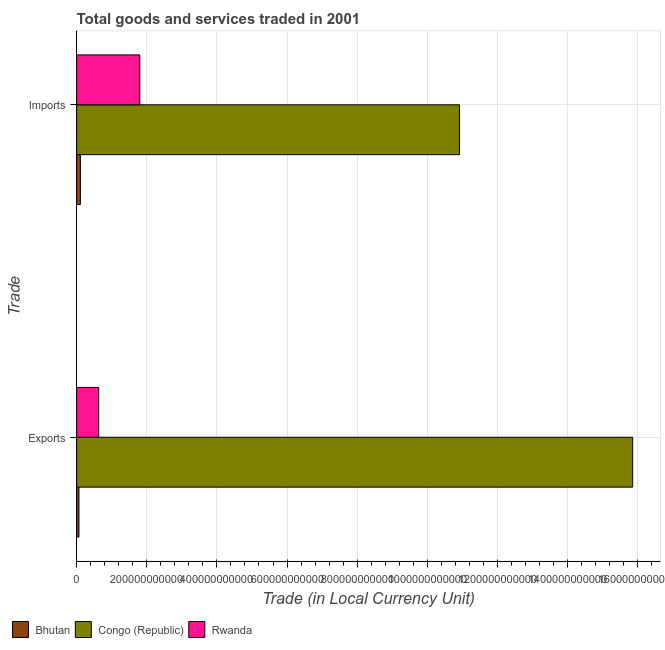How many groups of bars are there?
Your answer should be very brief. 2. Are the number of bars per tick equal to the number of legend labels?
Make the answer very short. Yes. How many bars are there on the 2nd tick from the bottom?
Offer a terse response. 3. What is the label of the 1st group of bars from the top?
Your answer should be compact. Imports. What is the imports of goods and services in Congo (Republic)?
Provide a short and direct response. 1.09e+12. Across all countries, what is the maximum export of goods and services?
Your answer should be compact. 1.59e+12. Across all countries, what is the minimum export of goods and services?
Your answer should be very brief. 6.51e+09. In which country was the export of goods and services maximum?
Give a very brief answer. Congo (Republic). In which country was the imports of goods and services minimum?
Your answer should be compact. Bhutan. What is the total export of goods and services in the graph?
Provide a short and direct response. 1.66e+12. What is the difference between the export of goods and services in Bhutan and that in Congo (Republic)?
Give a very brief answer. -1.58e+12. What is the difference between the imports of goods and services in Bhutan and the export of goods and services in Rwanda?
Your response must be concise. -5.23e+1. What is the average imports of goods and services per country?
Your answer should be compact. 4.28e+11. What is the difference between the imports of goods and services and export of goods and services in Bhutan?
Ensure brevity in your answer.  4.12e+09. In how many countries, is the export of goods and services greater than 80000000000 LCU?
Your answer should be compact. 1. What is the ratio of the export of goods and services in Rwanda to that in Congo (Republic)?
Your answer should be very brief. 0.04. In how many countries, is the imports of goods and services greater than the average imports of goods and services taken over all countries?
Ensure brevity in your answer.  1. What does the 2nd bar from the top in Exports represents?
Provide a short and direct response. Congo (Republic). What does the 1st bar from the bottom in Exports represents?
Ensure brevity in your answer.  Bhutan. How many countries are there in the graph?
Give a very brief answer. 3. What is the difference between two consecutive major ticks on the X-axis?
Offer a terse response. 2.00e+11. Are the values on the major ticks of X-axis written in scientific E-notation?
Provide a succinct answer. No. Does the graph contain grids?
Your answer should be very brief. Yes. What is the title of the graph?
Provide a succinct answer. Total goods and services traded in 2001. Does "Japan" appear as one of the legend labels in the graph?
Offer a very short reply. No. What is the label or title of the X-axis?
Your answer should be compact. Trade (in Local Currency Unit). What is the label or title of the Y-axis?
Your response must be concise. Trade. What is the Trade (in Local Currency Unit) in Bhutan in Exports?
Provide a short and direct response. 6.51e+09. What is the Trade (in Local Currency Unit) in Congo (Republic) in Exports?
Offer a very short reply. 1.59e+12. What is the Trade (in Local Currency Unit) in Rwanda in Exports?
Keep it short and to the point. 6.29e+1. What is the Trade (in Local Currency Unit) of Bhutan in Imports?
Provide a succinct answer. 1.06e+1. What is the Trade (in Local Currency Unit) in Congo (Republic) in Imports?
Make the answer very short. 1.09e+12. What is the Trade (in Local Currency Unit) of Rwanda in Imports?
Your answer should be very brief. 1.80e+11. Across all Trade, what is the maximum Trade (in Local Currency Unit) in Bhutan?
Provide a succinct answer. 1.06e+1. Across all Trade, what is the maximum Trade (in Local Currency Unit) of Congo (Republic)?
Provide a succinct answer. 1.59e+12. Across all Trade, what is the maximum Trade (in Local Currency Unit) of Rwanda?
Your response must be concise. 1.80e+11. Across all Trade, what is the minimum Trade (in Local Currency Unit) in Bhutan?
Provide a short and direct response. 6.51e+09. Across all Trade, what is the minimum Trade (in Local Currency Unit) of Congo (Republic)?
Your answer should be compact. 1.09e+12. Across all Trade, what is the minimum Trade (in Local Currency Unit) in Rwanda?
Provide a short and direct response. 6.29e+1. What is the total Trade (in Local Currency Unit) of Bhutan in the graph?
Your answer should be compact. 1.71e+1. What is the total Trade (in Local Currency Unit) in Congo (Republic) in the graph?
Make the answer very short. 2.68e+12. What is the total Trade (in Local Currency Unit) of Rwanda in the graph?
Your answer should be compact. 2.43e+11. What is the difference between the Trade (in Local Currency Unit) of Bhutan in Exports and that in Imports?
Give a very brief answer. -4.12e+09. What is the difference between the Trade (in Local Currency Unit) in Congo (Republic) in Exports and that in Imports?
Keep it short and to the point. 4.94e+11. What is the difference between the Trade (in Local Currency Unit) in Rwanda in Exports and that in Imports?
Make the answer very short. -1.17e+11. What is the difference between the Trade (in Local Currency Unit) in Bhutan in Exports and the Trade (in Local Currency Unit) in Congo (Republic) in Imports?
Provide a succinct answer. -1.09e+12. What is the difference between the Trade (in Local Currency Unit) in Bhutan in Exports and the Trade (in Local Currency Unit) in Rwanda in Imports?
Your answer should be very brief. -1.74e+11. What is the difference between the Trade (in Local Currency Unit) of Congo (Republic) in Exports and the Trade (in Local Currency Unit) of Rwanda in Imports?
Your response must be concise. 1.41e+12. What is the average Trade (in Local Currency Unit) in Bhutan per Trade?
Give a very brief answer. 8.56e+09. What is the average Trade (in Local Currency Unit) in Congo (Republic) per Trade?
Your response must be concise. 1.34e+12. What is the average Trade (in Local Currency Unit) of Rwanda per Trade?
Keep it short and to the point. 1.22e+11. What is the difference between the Trade (in Local Currency Unit) of Bhutan and Trade (in Local Currency Unit) of Congo (Republic) in Exports?
Give a very brief answer. -1.58e+12. What is the difference between the Trade (in Local Currency Unit) of Bhutan and Trade (in Local Currency Unit) of Rwanda in Exports?
Offer a terse response. -5.64e+1. What is the difference between the Trade (in Local Currency Unit) in Congo (Republic) and Trade (in Local Currency Unit) in Rwanda in Exports?
Your response must be concise. 1.52e+12. What is the difference between the Trade (in Local Currency Unit) in Bhutan and Trade (in Local Currency Unit) in Congo (Republic) in Imports?
Your response must be concise. -1.08e+12. What is the difference between the Trade (in Local Currency Unit) in Bhutan and Trade (in Local Currency Unit) in Rwanda in Imports?
Make the answer very short. -1.69e+11. What is the difference between the Trade (in Local Currency Unit) of Congo (Republic) and Trade (in Local Currency Unit) of Rwanda in Imports?
Your answer should be very brief. 9.12e+11. What is the ratio of the Trade (in Local Currency Unit) of Bhutan in Exports to that in Imports?
Provide a succinct answer. 0.61. What is the ratio of the Trade (in Local Currency Unit) of Congo (Republic) in Exports to that in Imports?
Make the answer very short. 1.45. What is the ratio of the Trade (in Local Currency Unit) in Rwanda in Exports to that in Imports?
Your response must be concise. 0.35. What is the difference between the highest and the second highest Trade (in Local Currency Unit) in Bhutan?
Provide a succinct answer. 4.12e+09. What is the difference between the highest and the second highest Trade (in Local Currency Unit) in Congo (Republic)?
Keep it short and to the point. 4.94e+11. What is the difference between the highest and the second highest Trade (in Local Currency Unit) of Rwanda?
Your response must be concise. 1.17e+11. What is the difference between the highest and the lowest Trade (in Local Currency Unit) of Bhutan?
Offer a terse response. 4.12e+09. What is the difference between the highest and the lowest Trade (in Local Currency Unit) of Congo (Republic)?
Provide a short and direct response. 4.94e+11. What is the difference between the highest and the lowest Trade (in Local Currency Unit) in Rwanda?
Your answer should be compact. 1.17e+11. 